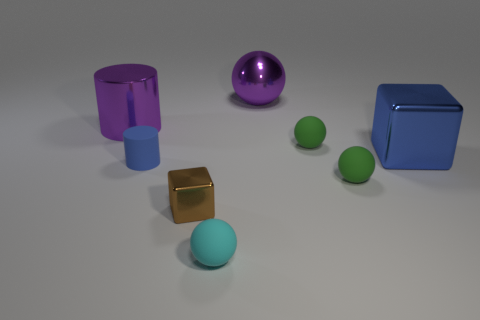Subtract all green blocks. How many green balls are left? 2 Subtract all small cyan balls. How many balls are left? 3 Add 2 brown metal cubes. How many objects exist? 10 Subtract all purple balls. How many balls are left? 3 Subtract all cylinders. How many objects are left? 6 Add 2 tiny green rubber balls. How many tiny green rubber balls exist? 4 Subtract 0 cyan cylinders. How many objects are left? 8 Subtract all brown blocks. Subtract all green spheres. How many blocks are left? 1 Subtract all small purple matte cylinders. Subtract all blue rubber cylinders. How many objects are left? 7 Add 7 small blue objects. How many small blue objects are left? 8 